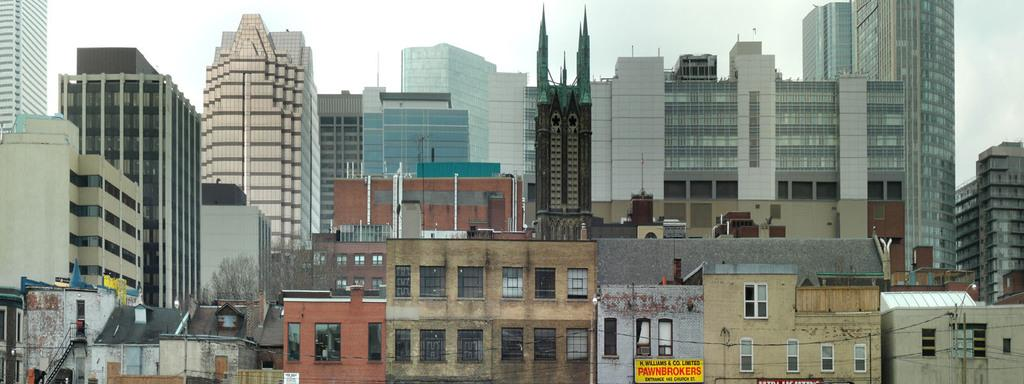<image>
Render a clear and concise summary of the photo. H Williams & Co Pawnbrokers sign in a cityscape. 